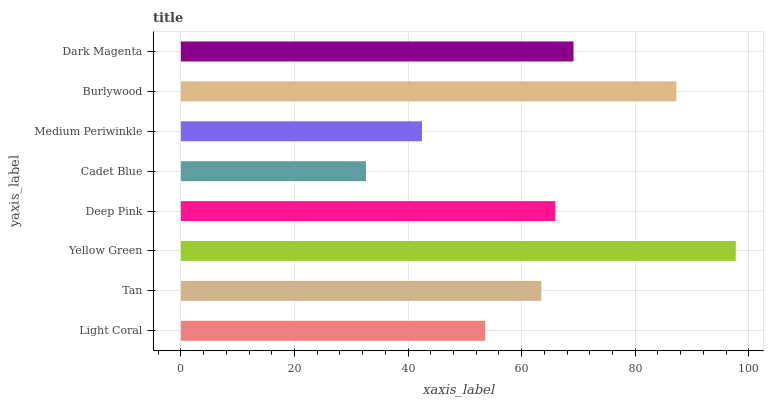Is Cadet Blue the minimum?
Answer yes or no. Yes. Is Yellow Green the maximum?
Answer yes or no. Yes. Is Tan the minimum?
Answer yes or no. No. Is Tan the maximum?
Answer yes or no. No. Is Tan greater than Light Coral?
Answer yes or no. Yes. Is Light Coral less than Tan?
Answer yes or no. Yes. Is Light Coral greater than Tan?
Answer yes or no. No. Is Tan less than Light Coral?
Answer yes or no. No. Is Deep Pink the high median?
Answer yes or no. Yes. Is Tan the low median?
Answer yes or no. Yes. Is Tan the high median?
Answer yes or no. No. Is Dark Magenta the low median?
Answer yes or no. No. 